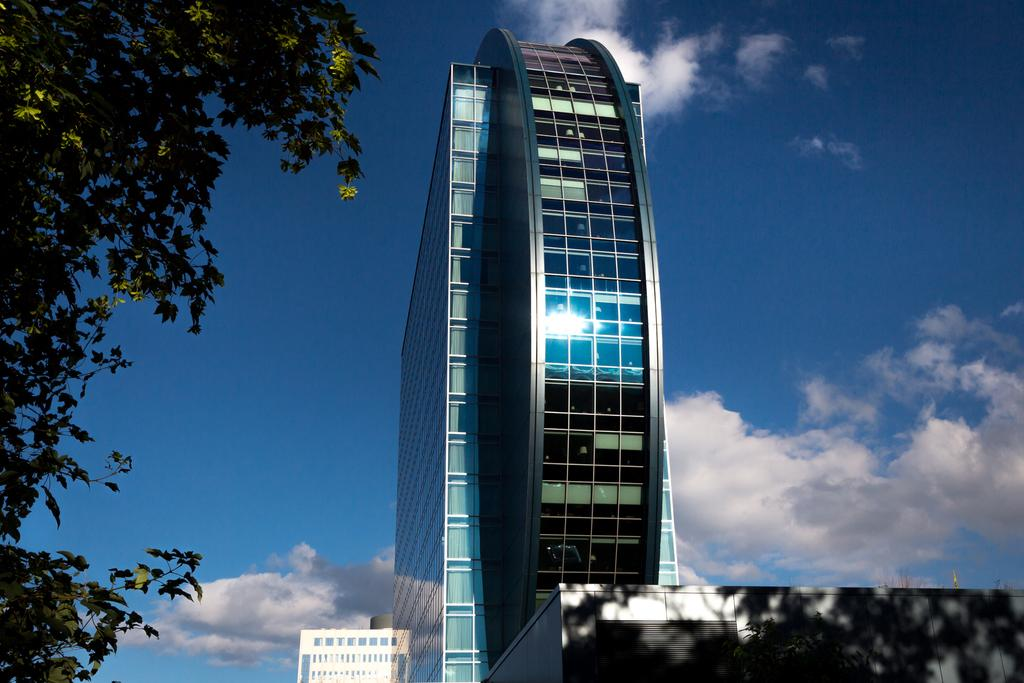What type of buildings can be seen in the image? There are buildings with glass windows in the image. What is visible in the background of the image? The background of the image includes the sky with clouds. Where is the tree located in the image? The tree is on the left side of the image. Can you tell me how many connections the net has in the image? There is no net present in the image, so it is not possible to determine the number of connections. 